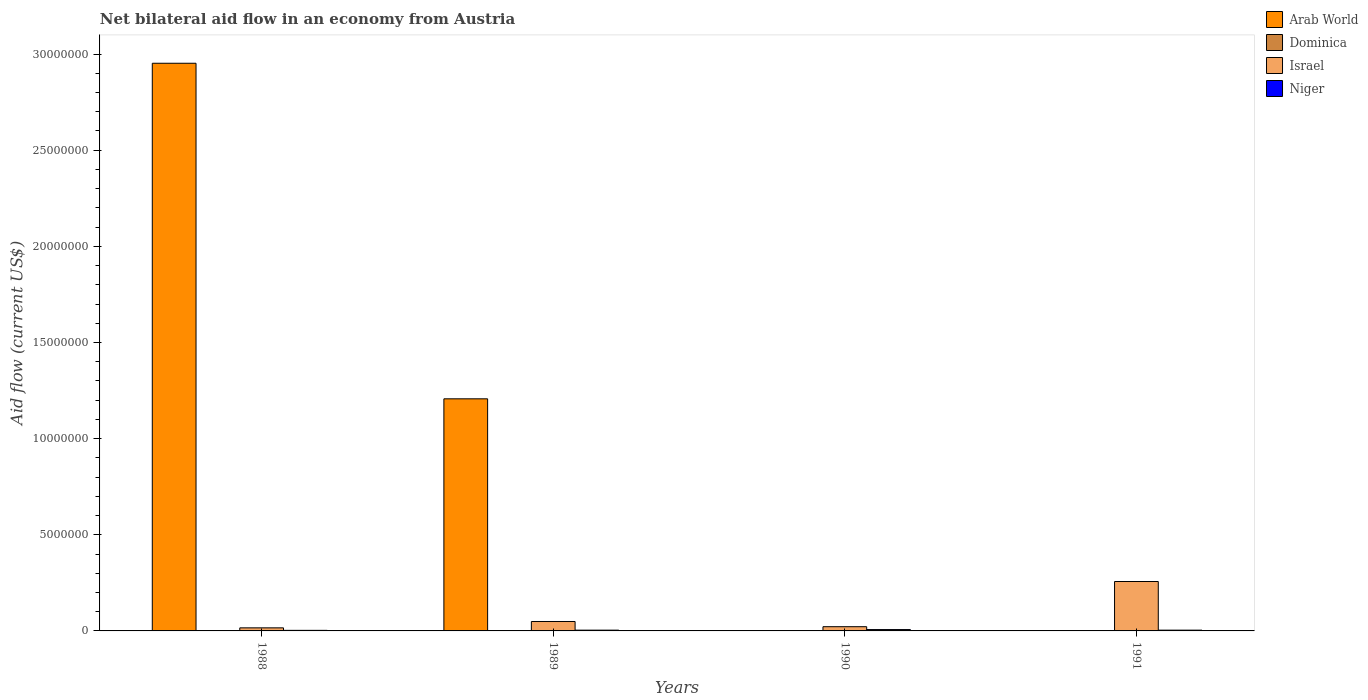How many groups of bars are there?
Your answer should be compact. 4. Are the number of bars per tick equal to the number of legend labels?
Offer a very short reply. No. Are the number of bars on each tick of the X-axis equal?
Provide a succinct answer. No. How many bars are there on the 2nd tick from the left?
Offer a terse response. 4. What is the label of the 2nd group of bars from the left?
Your response must be concise. 1989. In how many cases, is the number of bars for a given year not equal to the number of legend labels?
Offer a terse response. 2. What is the net bilateral aid flow in Arab World in 1990?
Your answer should be very brief. 0. Across all years, what is the maximum net bilateral aid flow in Israel?
Provide a succinct answer. 2.57e+06. In which year was the net bilateral aid flow in Arab World maximum?
Your answer should be very brief. 1988. What is the total net bilateral aid flow in Niger in the graph?
Your answer should be very brief. 1.80e+05. What is the difference between the net bilateral aid flow in Arab World in 1988 and that in 1989?
Your answer should be compact. 1.74e+07. What is the difference between the net bilateral aid flow in Dominica in 1988 and the net bilateral aid flow in Israel in 1991?
Offer a very short reply. -2.56e+06. What is the average net bilateral aid flow in Niger per year?
Your answer should be very brief. 4.50e+04. In the year 1989, what is the difference between the net bilateral aid flow in Niger and net bilateral aid flow in Arab World?
Ensure brevity in your answer.  -1.20e+07. In how many years, is the net bilateral aid flow in Israel greater than 4000000 US$?
Your response must be concise. 0. What is the ratio of the net bilateral aid flow in Arab World in 1988 to that in 1989?
Offer a terse response. 2.45. What is the difference between the highest and the second highest net bilateral aid flow in Israel?
Make the answer very short. 2.08e+06. What is the difference between the highest and the lowest net bilateral aid flow in Arab World?
Your answer should be very brief. 2.95e+07. Is it the case that in every year, the sum of the net bilateral aid flow in Israel and net bilateral aid flow in Arab World is greater than the sum of net bilateral aid flow in Dominica and net bilateral aid flow in Niger?
Make the answer very short. Yes. Is it the case that in every year, the sum of the net bilateral aid flow in Israel and net bilateral aid flow in Dominica is greater than the net bilateral aid flow in Arab World?
Keep it short and to the point. No. Are all the bars in the graph horizontal?
Your answer should be compact. No. What is the difference between two consecutive major ticks on the Y-axis?
Offer a very short reply. 5.00e+06. Does the graph contain grids?
Keep it short and to the point. No. What is the title of the graph?
Provide a short and direct response. Net bilateral aid flow in an economy from Austria. What is the label or title of the Y-axis?
Keep it short and to the point. Aid flow (current US$). What is the Aid flow (current US$) of Arab World in 1988?
Ensure brevity in your answer.  2.95e+07. What is the Aid flow (current US$) of Dominica in 1988?
Your answer should be compact. 10000. What is the Aid flow (current US$) of Israel in 1988?
Your answer should be compact. 1.60e+05. What is the Aid flow (current US$) in Niger in 1988?
Keep it short and to the point. 3.00e+04. What is the Aid flow (current US$) of Arab World in 1989?
Provide a succinct answer. 1.21e+07. What is the Aid flow (current US$) of Dominica in 1989?
Ensure brevity in your answer.  10000. What is the Aid flow (current US$) in Niger in 1989?
Give a very brief answer. 4.00e+04. What is the Aid flow (current US$) of Dominica in 1990?
Give a very brief answer. 10000. What is the Aid flow (current US$) in Israel in 1990?
Provide a succinct answer. 2.20e+05. What is the Aid flow (current US$) in Niger in 1990?
Offer a terse response. 7.00e+04. What is the Aid flow (current US$) of Arab World in 1991?
Make the answer very short. 0. What is the Aid flow (current US$) of Israel in 1991?
Keep it short and to the point. 2.57e+06. Across all years, what is the maximum Aid flow (current US$) of Arab World?
Offer a very short reply. 2.95e+07. Across all years, what is the maximum Aid flow (current US$) of Israel?
Give a very brief answer. 2.57e+06. Across all years, what is the minimum Aid flow (current US$) of Arab World?
Your response must be concise. 0. Across all years, what is the minimum Aid flow (current US$) of Dominica?
Ensure brevity in your answer.  10000. What is the total Aid flow (current US$) of Arab World in the graph?
Ensure brevity in your answer.  4.16e+07. What is the total Aid flow (current US$) of Israel in the graph?
Keep it short and to the point. 3.44e+06. What is the total Aid flow (current US$) of Niger in the graph?
Provide a succinct answer. 1.80e+05. What is the difference between the Aid flow (current US$) in Arab World in 1988 and that in 1989?
Your answer should be compact. 1.74e+07. What is the difference between the Aid flow (current US$) of Dominica in 1988 and that in 1989?
Provide a short and direct response. 0. What is the difference between the Aid flow (current US$) in Israel in 1988 and that in 1989?
Your response must be concise. -3.30e+05. What is the difference between the Aid flow (current US$) in Dominica in 1988 and that in 1990?
Your response must be concise. 0. What is the difference between the Aid flow (current US$) of Israel in 1988 and that in 1990?
Keep it short and to the point. -6.00e+04. What is the difference between the Aid flow (current US$) in Dominica in 1988 and that in 1991?
Make the answer very short. 0. What is the difference between the Aid flow (current US$) in Israel in 1988 and that in 1991?
Your answer should be very brief. -2.41e+06. What is the difference between the Aid flow (current US$) of Dominica in 1989 and that in 1990?
Provide a succinct answer. 0. What is the difference between the Aid flow (current US$) in Niger in 1989 and that in 1990?
Provide a short and direct response. -3.00e+04. What is the difference between the Aid flow (current US$) in Israel in 1989 and that in 1991?
Provide a succinct answer. -2.08e+06. What is the difference between the Aid flow (current US$) of Dominica in 1990 and that in 1991?
Give a very brief answer. 0. What is the difference between the Aid flow (current US$) of Israel in 1990 and that in 1991?
Provide a short and direct response. -2.35e+06. What is the difference between the Aid flow (current US$) in Niger in 1990 and that in 1991?
Offer a very short reply. 3.00e+04. What is the difference between the Aid flow (current US$) of Arab World in 1988 and the Aid flow (current US$) of Dominica in 1989?
Your response must be concise. 2.95e+07. What is the difference between the Aid flow (current US$) of Arab World in 1988 and the Aid flow (current US$) of Israel in 1989?
Your response must be concise. 2.90e+07. What is the difference between the Aid flow (current US$) in Arab World in 1988 and the Aid flow (current US$) in Niger in 1989?
Offer a terse response. 2.95e+07. What is the difference between the Aid flow (current US$) of Dominica in 1988 and the Aid flow (current US$) of Israel in 1989?
Ensure brevity in your answer.  -4.80e+05. What is the difference between the Aid flow (current US$) of Dominica in 1988 and the Aid flow (current US$) of Niger in 1989?
Keep it short and to the point. -3.00e+04. What is the difference between the Aid flow (current US$) in Israel in 1988 and the Aid flow (current US$) in Niger in 1989?
Provide a short and direct response. 1.20e+05. What is the difference between the Aid flow (current US$) of Arab World in 1988 and the Aid flow (current US$) of Dominica in 1990?
Your answer should be very brief. 2.95e+07. What is the difference between the Aid flow (current US$) of Arab World in 1988 and the Aid flow (current US$) of Israel in 1990?
Offer a terse response. 2.93e+07. What is the difference between the Aid flow (current US$) in Arab World in 1988 and the Aid flow (current US$) in Niger in 1990?
Your response must be concise. 2.94e+07. What is the difference between the Aid flow (current US$) in Dominica in 1988 and the Aid flow (current US$) in Israel in 1990?
Provide a succinct answer. -2.10e+05. What is the difference between the Aid flow (current US$) of Arab World in 1988 and the Aid flow (current US$) of Dominica in 1991?
Your answer should be very brief. 2.95e+07. What is the difference between the Aid flow (current US$) in Arab World in 1988 and the Aid flow (current US$) in Israel in 1991?
Make the answer very short. 2.70e+07. What is the difference between the Aid flow (current US$) in Arab World in 1988 and the Aid flow (current US$) in Niger in 1991?
Provide a short and direct response. 2.95e+07. What is the difference between the Aid flow (current US$) in Dominica in 1988 and the Aid flow (current US$) in Israel in 1991?
Make the answer very short. -2.56e+06. What is the difference between the Aid flow (current US$) in Arab World in 1989 and the Aid flow (current US$) in Dominica in 1990?
Your answer should be very brief. 1.21e+07. What is the difference between the Aid flow (current US$) of Arab World in 1989 and the Aid flow (current US$) of Israel in 1990?
Provide a succinct answer. 1.18e+07. What is the difference between the Aid flow (current US$) in Arab World in 1989 and the Aid flow (current US$) in Niger in 1990?
Keep it short and to the point. 1.20e+07. What is the difference between the Aid flow (current US$) of Arab World in 1989 and the Aid flow (current US$) of Dominica in 1991?
Ensure brevity in your answer.  1.21e+07. What is the difference between the Aid flow (current US$) of Arab World in 1989 and the Aid flow (current US$) of Israel in 1991?
Provide a short and direct response. 9.50e+06. What is the difference between the Aid flow (current US$) of Arab World in 1989 and the Aid flow (current US$) of Niger in 1991?
Provide a succinct answer. 1.20e+07. What is the difference between the Aid flow (current US$) of Dominica in 1989 and the Aid flow (current US$) of Israel in 1991?
Offer a terse response. -2.56e+06. What is the difference between the Aid flow (current US$) of Israel in 1989 and the Aid flow (current US$) of Niger in 1991?
Keep it short and to the point. 4.50e+05. What is the difference between the Aid flow (current US$) in Dominica in 1990 and the Aid flow (current US$) in Israel in 1991?
Give a very brief answer. -2.56e+06. What is the difference between the Aid flow (current US$) of Dominica in 1990 and the Aid flow (current US$) of Niger in 1991?
Your answer should be very brief. -3.00e+04. What is the difference between the Aid flow (current US$) of Israel in 1990 and the Aid flow (current US$) of Niger in 1991?
Make the answer very short. 1.80e+05. What is the average Aid flow (current US$) of Arab World per year?
Offer a very short reply. 1.04e+07. What is the average Aid flow (current US$) of Israel per year?
Make the answer very short. 8.60e+05. What is the average Aid flow (current US$) in Niger per year?
Your response must be concise. 4.50e+04. In the year 1988, what is the difference between the Aid flow (current US$) of Arab World and Aid flow (current US$) of Dominica?
Offer a terse response. 2.95e+07. In the year 1988, what is the difference between the Aid flow (current US$) in Arab World and Aid flow (current US$) in Israel?
Keep it short and to the point. 2.94e+07. In the year 1988, what is the difference between the Aid flow (current US$) of Arab World and Aid flow (current US$) of Niger?
Offer a very short reply. 2.95e+07. In the year 1988, what is the difference between the Aid flow (current US$) of Dominica and Aid flow (current US$) of Israel?
Ensure brevity in your answer.  -1.50e+05. In the year 1988, what is the difference between the Aid flow (current US$) of Dominica and Aid flow (current US$) of Niger?
Provide a succinct answer. -2.00e+04. In the year 1989, what is the difference between the Aid flow (current US$) in Arab World and Aid flow (current US$) in Dominica?
Ensure brevity in your answer.  1.21e+07. In the year 1989, what is the difference between the Aid flow (current US$) of Arab World and Aid flow (current US$) of Israel?
Give a very brief answer. 1.16e+07. In the year 1989, what is the difference between the Aid flow (current US$) of Arab World and Aid flow (current US$) of Niger?
Keep it short and to the point. 1.20e+07. In the year 1989, what is the difference between the Aid flow (current US$) of Dominica and Aid flow (current US$) of Israel?
Your answer should be compact. -4.80e+05. In the year 1989, what is the difference between the Aid flow (current US$) in Dominica and Aid flow (current US$) in Niger?
Keep it short and to the point. -3.00e+04. In the year 1990, what is the difference between the Aid flow (current US$) in Israel and Aid flow (current US$) in Niger?
Give a very brief answer. 1.50e+05. In the year 1991, what is the difference between the Aid flow (current US$) of Dominica and Aid flow (current US$) of Israel?
Offer a terse response. -2.56e+06. In the year 1991, what is the difference between the Aid flow (current US$) of Israel and Aid flow (current US$) of Niger?
Your response must be concise. 2.53e+06. What is the ratio of the Aid flow (current US$) in Arab World in 1988 to that in 1989?
Provide a short and direct response. 2.45. What is the ratio of the Aid flow (current US$) of Dominica in 1988 to that in 1989?
Your answer should be very brief. 1. What is the ratio of the Aid flow (current US$) of Israel in 1988 to that in 1989?
Your answer should be compact. 0.33. What is the ratio of the Aid flow (current US$) in Niger in 1988 to that in 1989?
Ensure brevity in your answer.  0.75. What is the ratio of the Aid flow (current US$) of Dominica in 1988 to that in 1990?
Provide a short and direct response. 1. What is the ratio of the Aid flow (current US$) of Israel in 1988 to that in 1990?
Offer a terse response. 0.73. What is the ratio of the Aid flow (current US$) in Niger in 1988 to that in 1990?
Offer a terse response. 0.43. What is the ratio of the Aid flow (current US$) in Israel in 1988 to that in 1991?
Ensure brevity in your answer.  0.06. What is the ratio of the Aid flow (current US$) in Israel in 1989 to that in 1990?
Provide a short and direct response. 2.23. What is the ratio of the Aid flow (current US$) in Niger in 1989 to that in 1990?
Your answer should be very brief. 0.57. What is the ratio of the Aid flow (current US$) of Dominica in 1989 to that in 1991?
Offer a terse response. 1. What is the ratio of the Aid flow (current US$) in Israel in 1989 to that in 1991?
Provide a short and direct response. 0.19. What is the ratio of the Aid flow (current US$) of Niger in 1989 to that in 1991?
Your answer should be very brief. 1. What is the ratio of the Aid flow (current US$) of Dominica in 1990 to that in 1991?
Offer a terse response. 1. What is the ratio of the Aid flow (current US$) in Israel in 1990 to that in 1991?
Provide a short and direct response. 0.09. What is the difference between the highest and the second highest Aid flow (current US$) in Dominica?
Offer a very short reply. 0. What is the difference between the highest and the second highest Aid flow (current US$) of Israel?
Your answer should be very brief. 2.08e+06. What is the difference between the highest and the second highest Aid flow (current US$) of Niger?
Provide a succinct answer. 3.00e+04. What is the difference between the highest and the lowest Aid flow (current US$) in Arab World?
Your answer should be compact. 2.95e+07. What is the difference between the highest and the lowest Aid flow (current US$) in Israel?
Keep it short and to the point. 2.41e+06. What is the difference between the highest and the lowest Aid flow (current US$) of Niger?
Ensure brevity in your answer.  4.00e+04. 